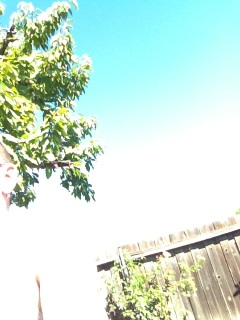What is this? This image appears to show a section of a tree with green leaves against a bright sky, possibly on a sunny day. The perspective suggests it might be taken from below the tree, looking up towards the sky. 